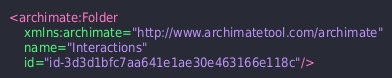<code> <loc_0><loc_0><loc_500><loc_500><_XML_><archimate:Folder
    xmlns:archimate="http://www.archimatetool.com/archimate"
    name="Interactions"
    id="id-3d3d1bfc7aa641e1ae30e463166e118c"/>
</code> 